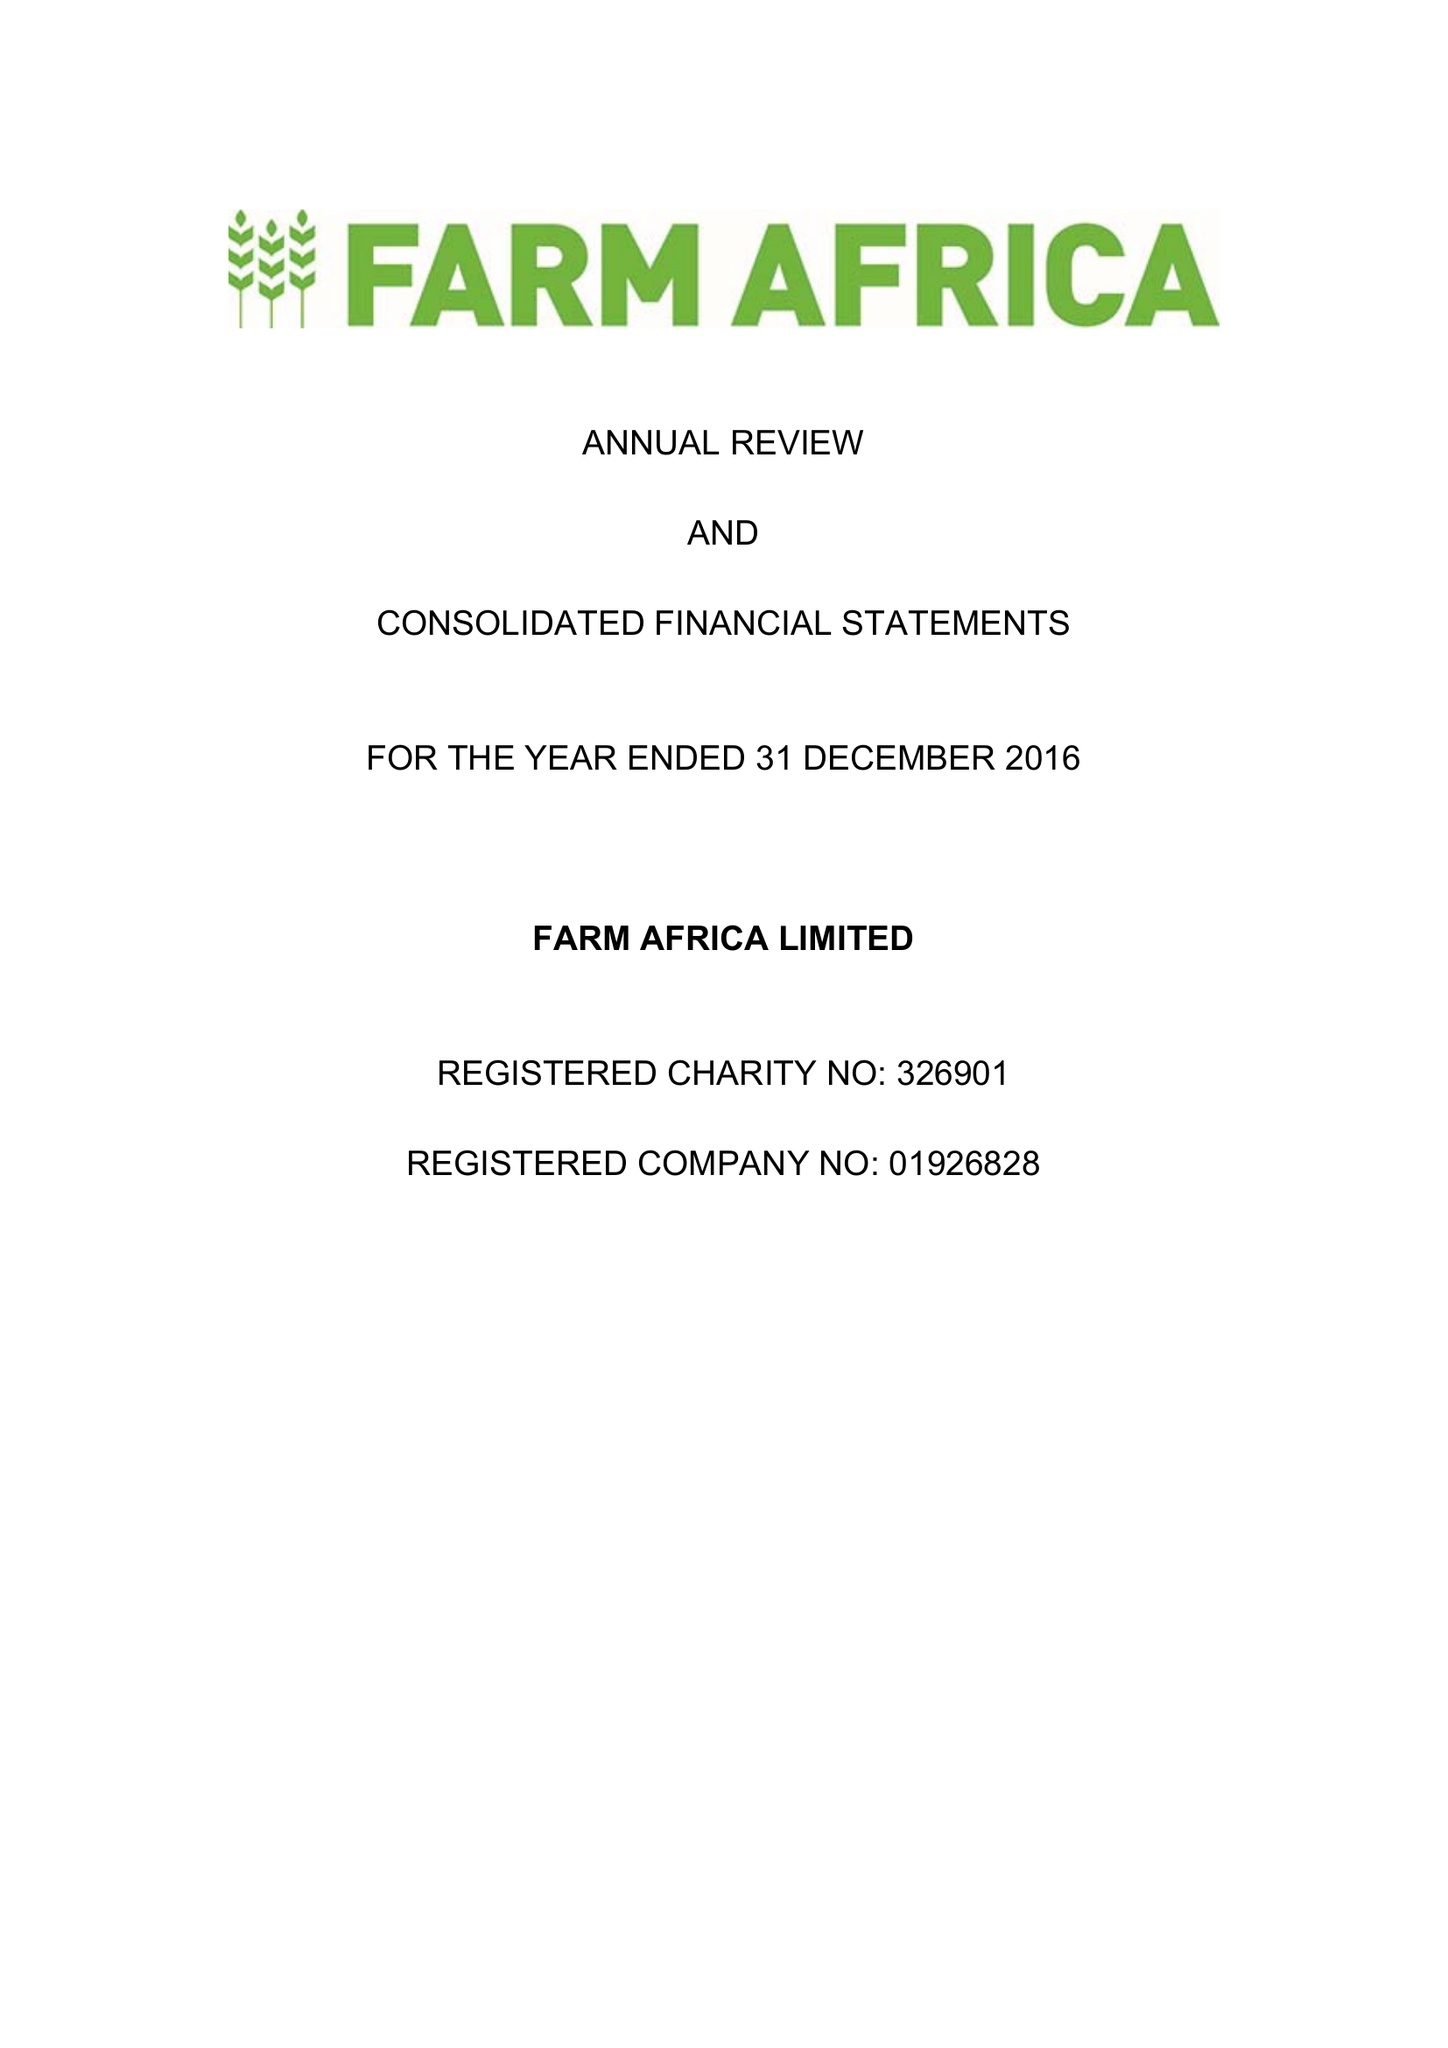What is the value for the address__postcode?
Answer the question using a single word or phrase. EC2Y 5DN 